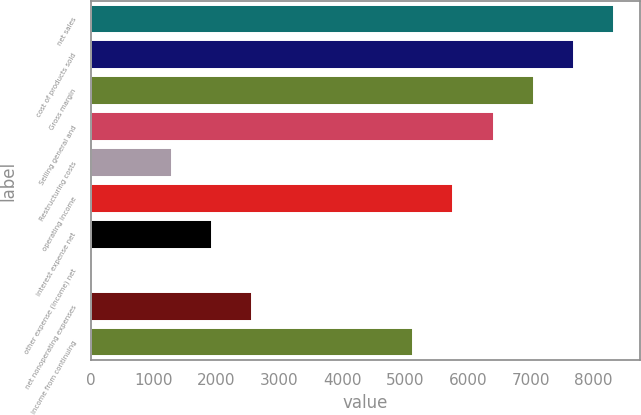Convert chart to OTSL. <chart><loc_0><loc_0><loc_500><loc_500><bar_chart><fcel>net sales<fcel>cost of products sold<fcel>Gross margin<fcel>Selling general and<fcel>Restructuring costs<fcel>operating income<fcel>interest expense net<fcel>other expense (income) net<fcel>net nonoperating expenses<fcel>income from continuing<nl><fcel>8327.3<fcel>7687.3<fcel>7047.3<fcel>6407.3<fcel>1287.3<fcel>5767.3<fcel>1927.3<fcel>7.3<fcel>2567.3<fcel>5127.3<nl></chart> 